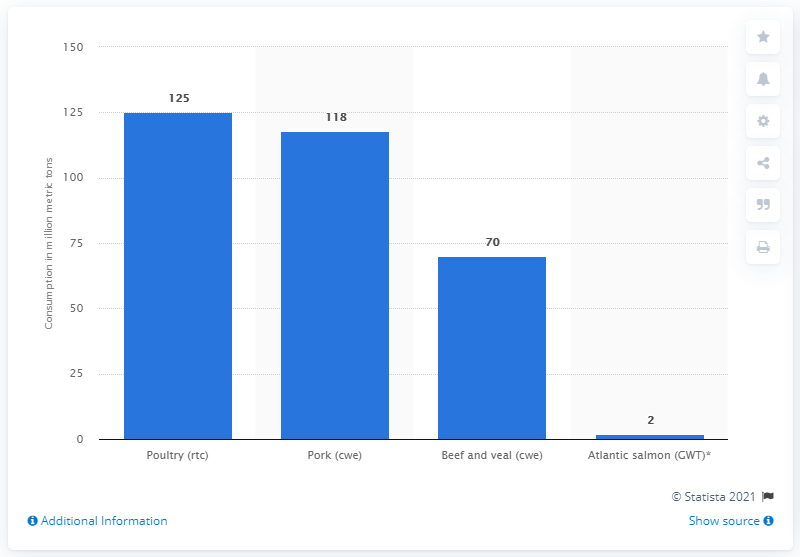Identify some key points in this picture. In 2019, the global consumption of ready-to-cook equivalent poultry amounted to approximately 125 million units. 